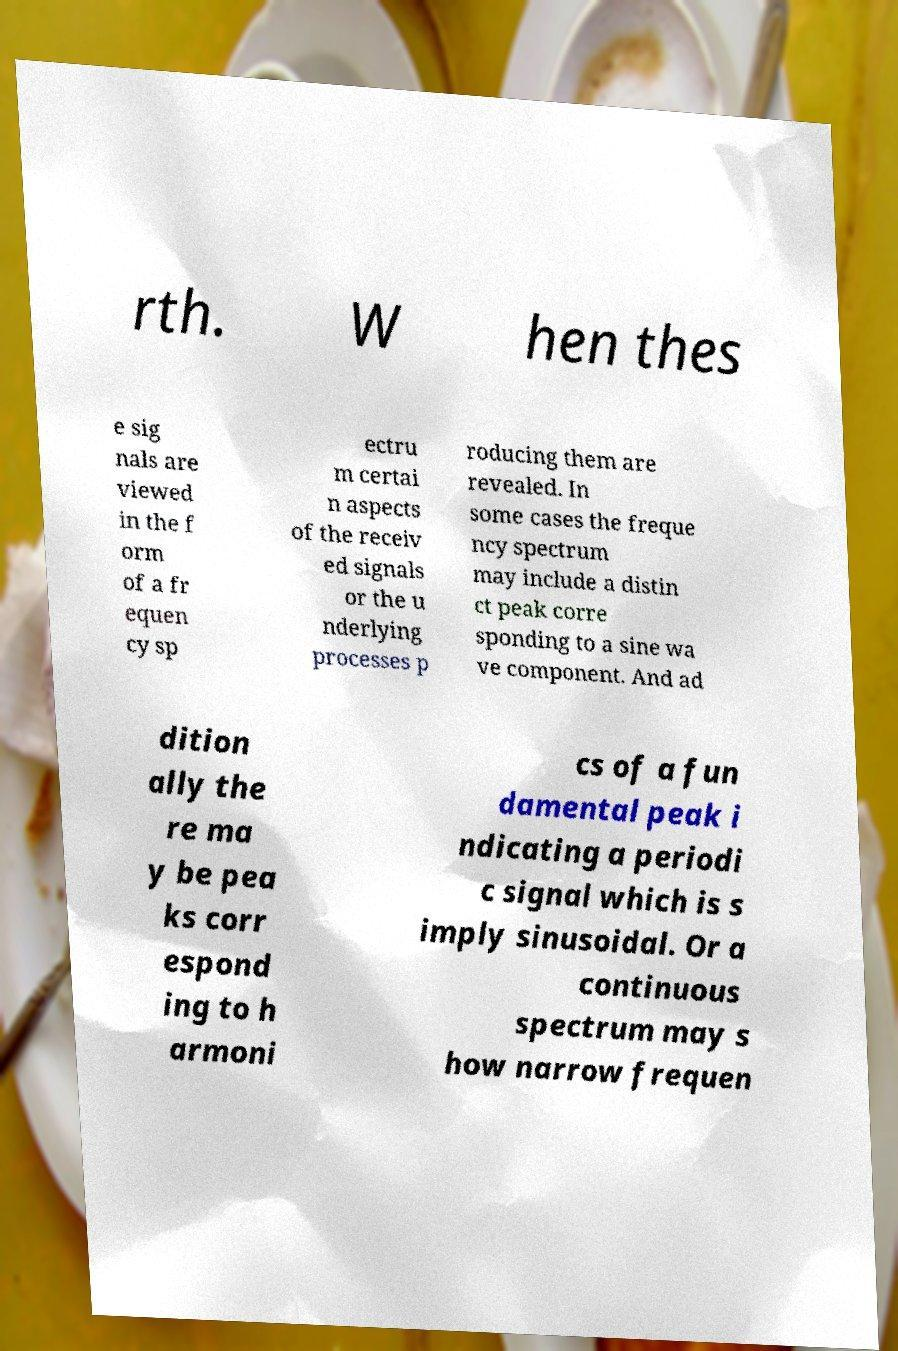What messages or text are displayed in this image? I need them in a readable, typed format. rth. W hen thes e sig nals are viewed in the f orm of a fr equen cy sp ectru m certai n aspects of the receiv ed signals or the u nderlying processes p roducing them are revealed. In some cases the freque ncy spectrum may include a distin ct peak corre sponding to a sine wa ve component. And ad dition ally the re ma y be pea ks corr espond ing to h armoni cs of a fun damental peak i ndicating a periodi c signal which is s imply sinusoidal. Or a continuous spectrum may s how narrow frequen 